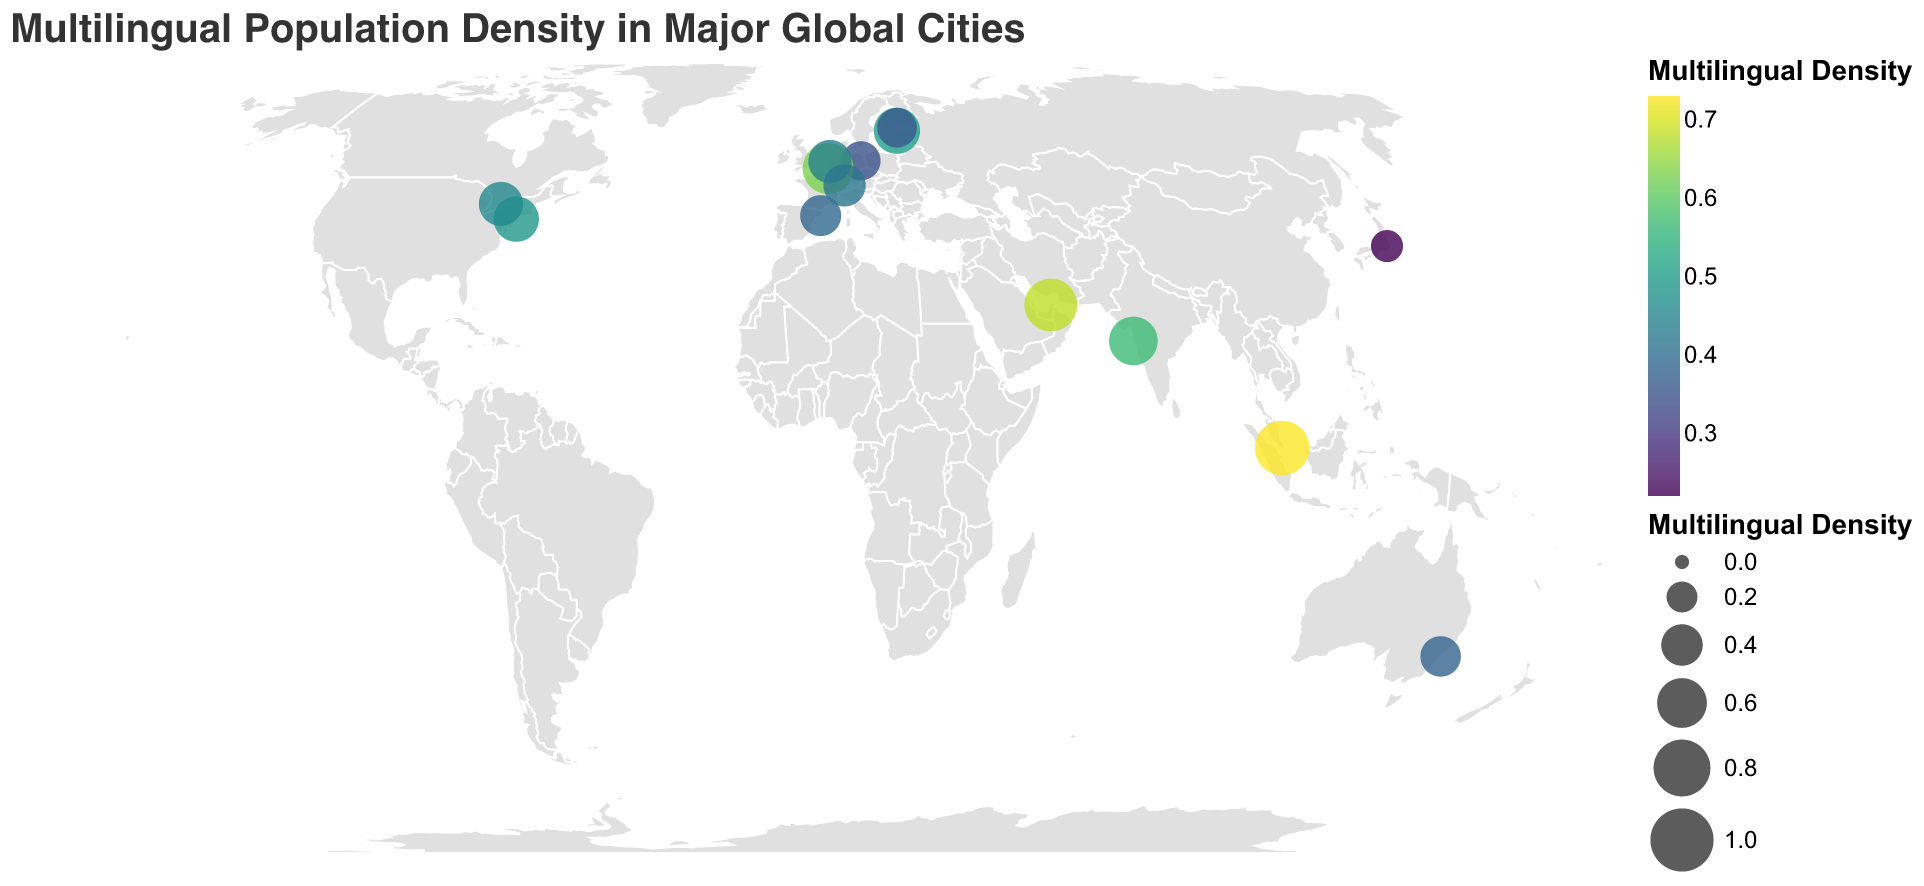What's the title of the figure? The title is usually located at the top of the figure and provides a brief description of the figure's content. In this case, it reads "Multilingual Population Density in Major Global Cities."
Answer: Multilingual Population Density in Major Global Cities Which city has the highest multilingual density? To find the city with the highest multilingual density, look for the circle with the largest size and the darkest color among the plotted cities. According to the data, it is Singapore with a density of 0.73.
Answer: Singapore Which three cities have the lowest multilingual density? Identify the three smallest and lightest-colored circles on the map. The data shows that these cities are Tokyo (0.22), Berlin (0.35), and Helsinki (0.36).
Answer: Tokyo, Berlin, Helsinki What is the multilingual density of Berlin? Locate Berlin on the map and examine the tooltip or visual indicators to find its multilingual density. According to the data provided, Berlin has a multilingual density of 0.35.
Answer: 0.35 How does the multilingual density of Tallinn compare to that of New York City? Compare the sizes and colors of the circles representing Tallinn and New York City. According to the data, Tallinn has a density of 0.51 and New York City has a density of 0.49. Therefore, Tallinn has a slightly higher density.
Answer: Tallinn is higher What is the average multilingual density of all cities listed? To compute the average, sum all the multilingual densities and divide by the number of cities. The total sum is 0.35 + 0.51 + 0.49 + 0.73 + 0.46 + 0.63 + 0.39 + 0.44 + 0.68 + 0.42 + 0.57 + 0.22 + 0.38 + 0.36 = 6.63. There are 14 cities, so the average is 6.63/14 ≈ 0.47.
Answer: 0.47 Which continent seems to have the highest representation in terms of cities with high multilingual densities? Observing the geographic distribution, cities in Asia like Singapore and Dubai showcase high multilingual densities. Visually, Asia seems to have the highest representation.
Answer: Asia How does Zurich's multilingual density compare to the global average? First, calculate the global average density, which is approximately 0.47. Zurich has a density of 0.42, which is slightly below the global average.
Answer: Below Identify the city with a multilingual density in the middle range (around 0.4 to 0.5). Look for cities with density values within the specified range. According to the data, New York City (0.49), Toronto (0.46), and Amsterdam (0.44) fit within this middle range.
Answer: New York City, Toronto, Amsterdam How does the multilingual density in Toronto compare to that in Barcelona? Compare the sizes and colors of the circles for these cities. Toronto has a multilingual density of 0.46 and Barcelona has a density of 0.39. Toronto's density is higher.
Answer: Toronto is higher 